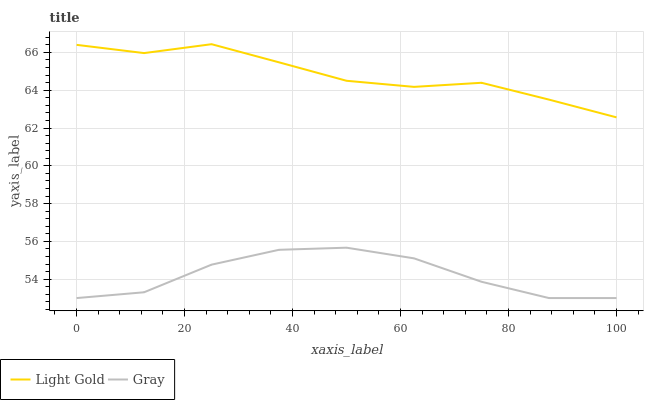Does Gray have the minimum area under the curve?
Answer yes or no. Yes. Does Light Gold have the maximum area under the curve?
Answer yes or no. Yes. Does Light Gold have the minimum area under the curve?
Answer yes or no. No. Is Light Gold the smoothest?
Answer yes or no. Yes. Is Gray the roughest?
Answer yes or no. Yes. Is Light Gold the roughest?
Answer yes or no. No. Does Gray have the lowest value?
Answer yes or no. Yes. Does Light Gold have the lowest value?
Answer yes or no. No. Does Light Gold have the highest value?
Answer yes or no. Yes. Is Gray less than Light Gold?
Answer yes or no. Yes. Is Light Gold greater than Gray?
Answer yes or no. Yes. Does Gray intersect Light Gold?
Answer yes or no. No. 